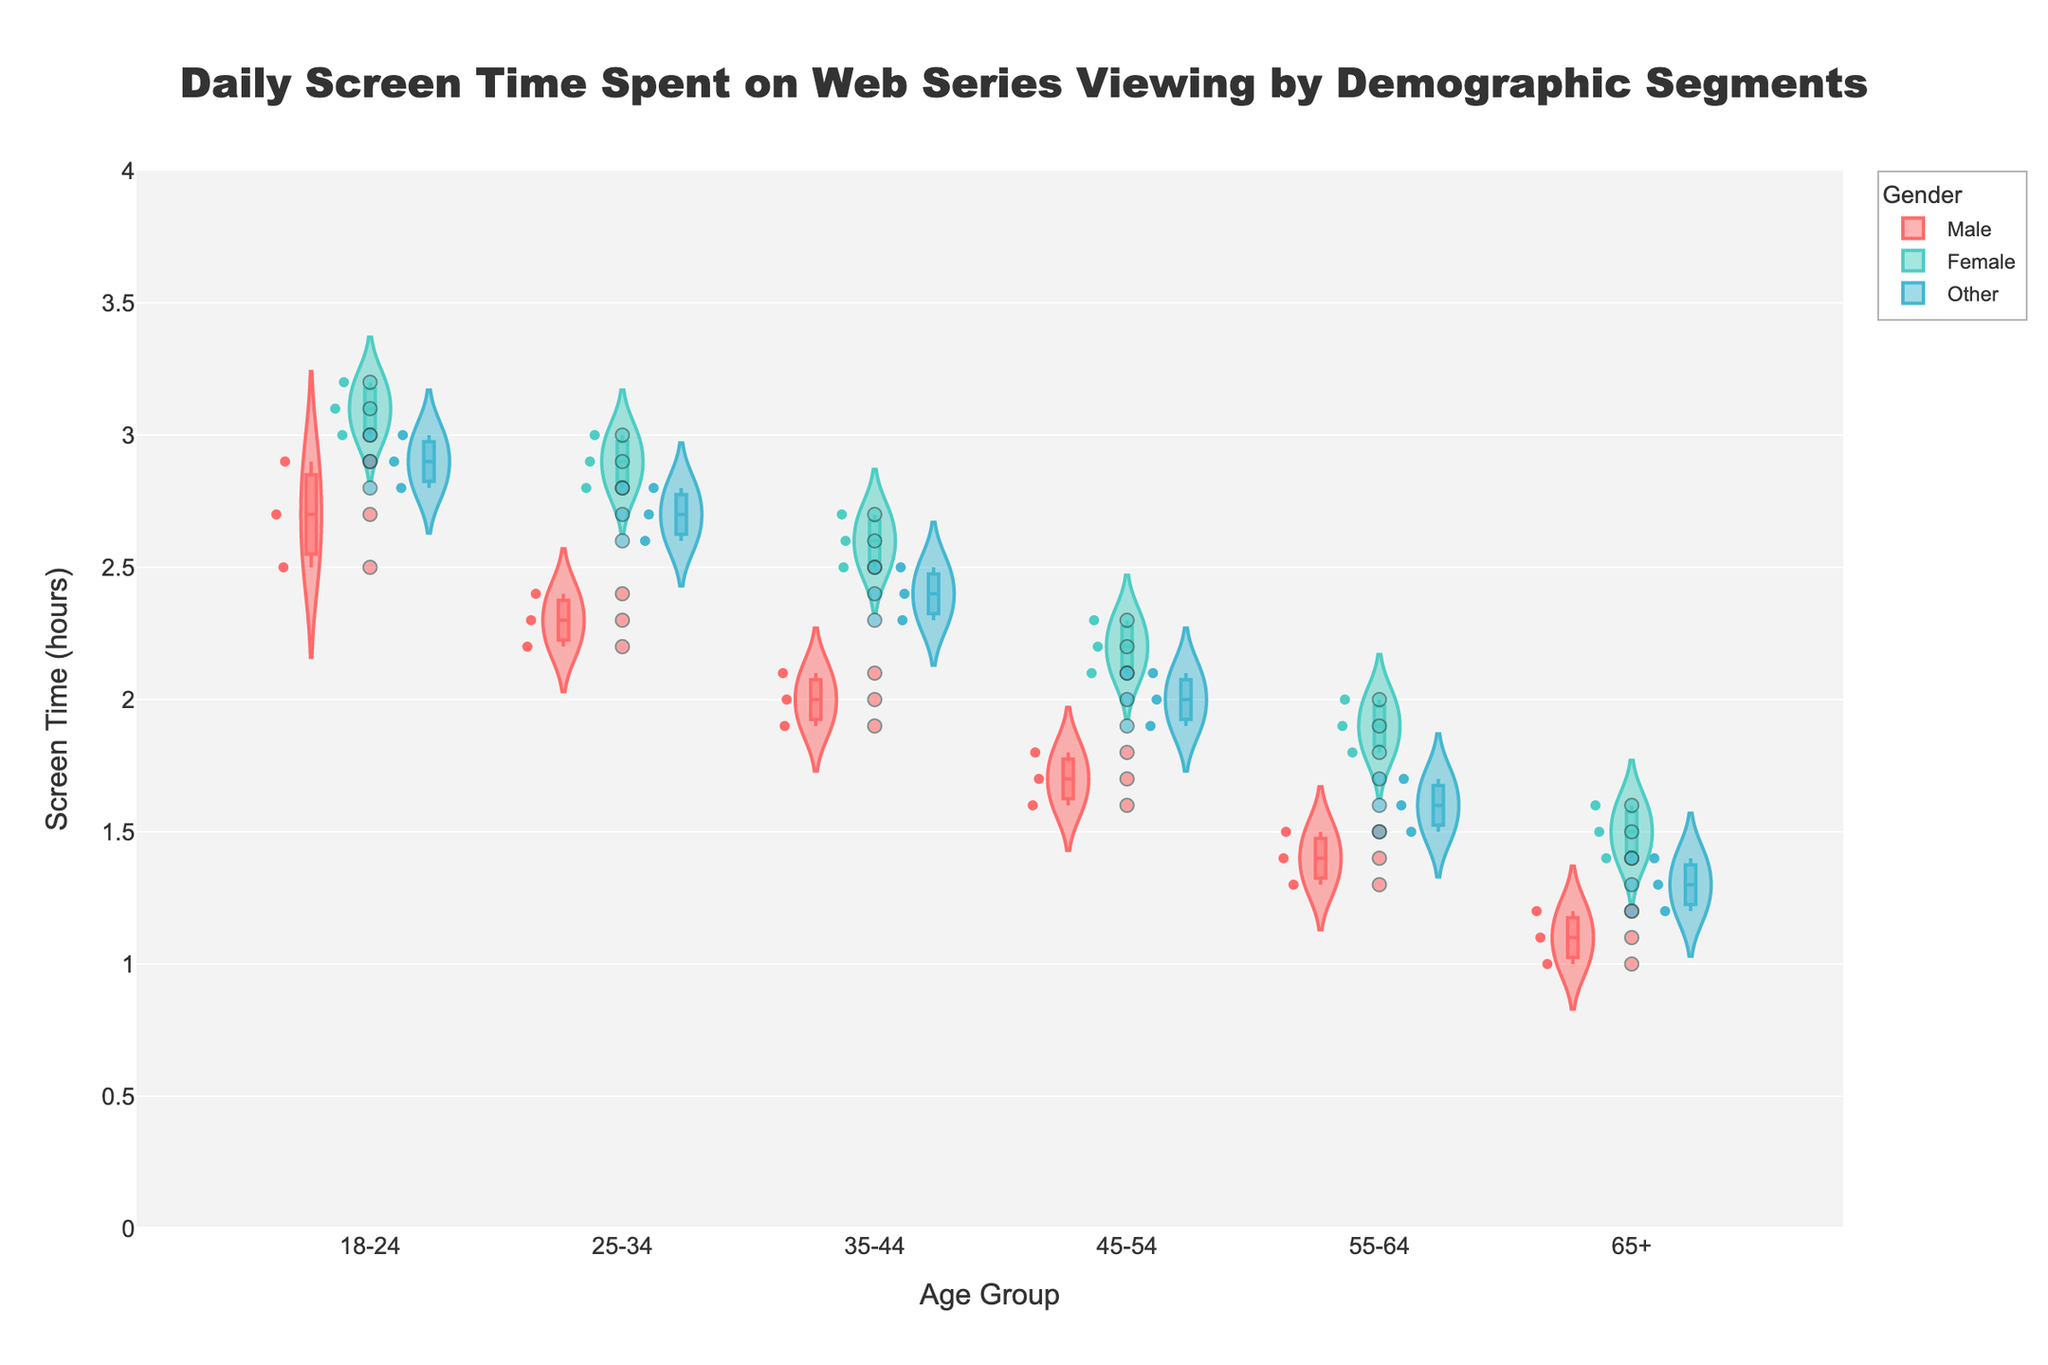What is the title of the chart? The title of the chart is located at the top of the figure and it reads "Daily Screen Time Spent on Web Series Viewing by Demographic Segments".
Answer: Daily Screen Time Spent on Web Series Viewing by Demographic Segments Which age group has the highest screen time for males? By examining the violin plot, particularly focusing on the male category, it is evident that the 18-24 age group has the highest screen time distribution, typically around 2.5 to 2.9 hours.
Answer: 18-24 What is the median screen time for the Female group in the 25-34 age category? The median value is depicted by a line within the box part of the violin plot. In the 25-34 age group for females, the median screen time is around 2.9 hours.
Answer: 2.9 hours How does the screen time of the 65+ age group compare between male and female viewers? To compare the screen time, look at the full range and median values for males and females within the 65+ age group. Males typically watch around 1.0 to 1.2 hours, while females watch around 1.4 to 1.6 hours. Therefore, females in this age group spend more time watching web series compared to males.
Answer: Females spend more time Are there more fluctuations in screen time for males or females in the 18-24 age group? The extent of fluctuations can be assessed by examining the width and spread of the violin plots and the dispersion of jittered points. In the 18-24 age group, females have a wider and more spread-out violin plot compared to males, indicating greater fluctuations in their screen time.
Answer: Females Which gender shows the least variability in screen time across all age groups? Variability can be assessed by examining the spread of the violin plots for each gender across all age groups. The male category consistently shows narrower plots, indicating less variability in screen time compared to females and others.
Answer: Males What is the average screen time for the 35-44 age group across all genders? To find the average, add the median screen times of all genders in the 35-44 age group. With medians of 2.0 for males, 2.6 for females, and 2.4 for others, the average is calculated as (2.0 + 2.6 + 2.4) / 3 = 2.33 hours.
Answer: 2.33 hours For the 55-64 age group, which gender has the smallest range in screen time? The range is determined by the distance between the minimum and maximum values within the violin plot. For the 55-64 age group, males show the smallest range, typically from 1.3 to 1.5 hours.
Answer: Males 